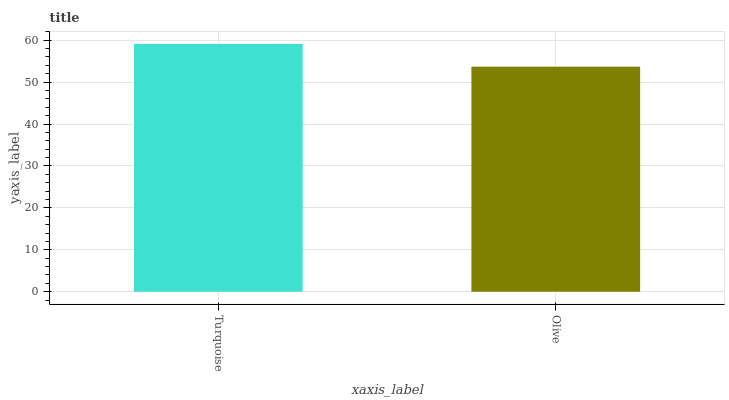Is Olive the minimum?
Answer yes or no. Yes. Is Turquoise the maximum?
Answer yes or no. Yes. Is Olive the maximum?
Answer yes or no. No. Is Turquoise greater than Olive?
Answer yes or no. Yes. Is Olive less than Turquoise?
Answer yes or no. Yes. Is Olive greater than Turquoise?
Answer yes or no. No. Is Turquoise less than Olive?
Answer yes or no. No. Is Turquoise the high median?
Answer yes or no. Yes. Is Olive the low median?
Answer yes or no. Yes. Is Olive the high median?
Answer yes or no. No. Is Turquoise the low median?
Answer yes or no. No. 